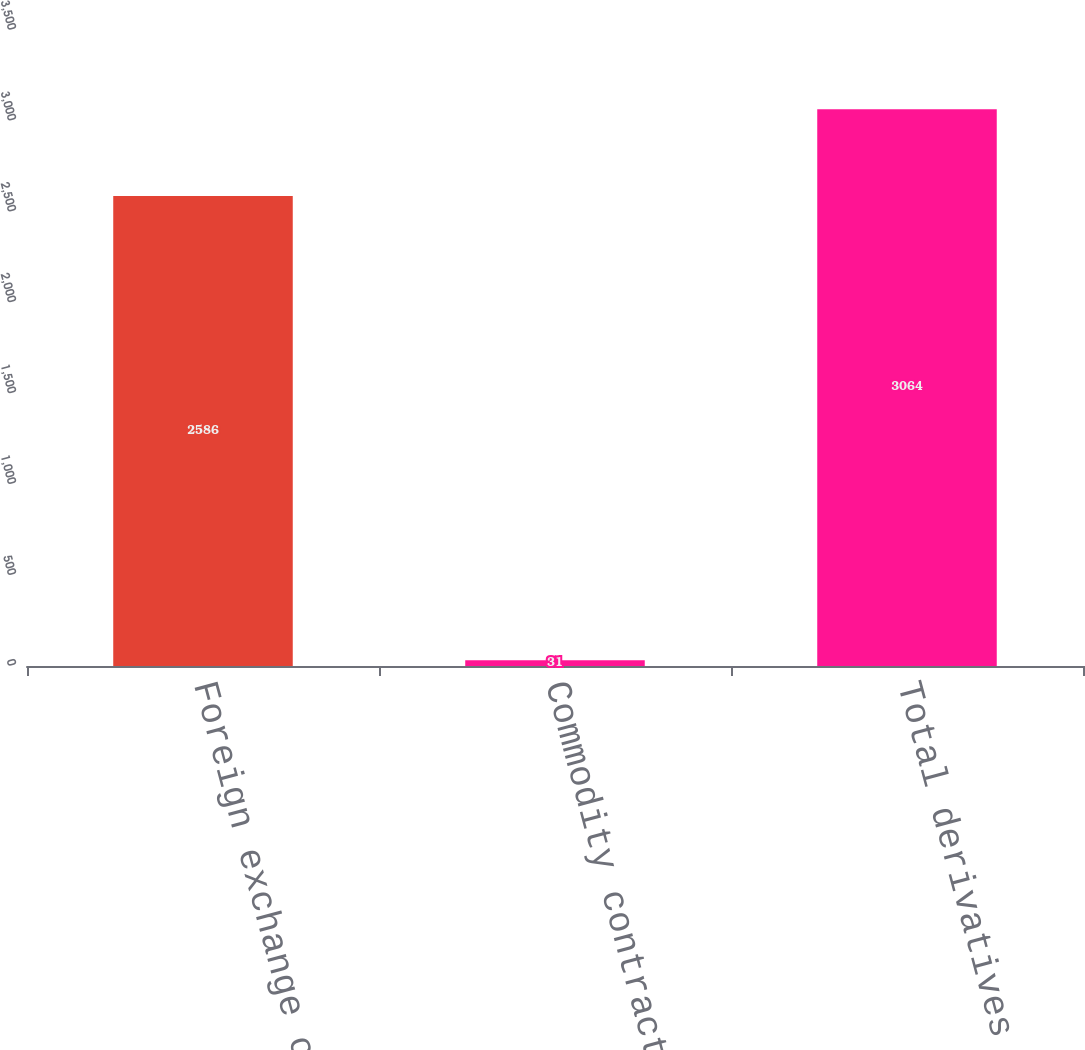Convert chart to OTSL. <chart><loc_0><loc_0><loc_500><loc_500><bar_chart><fcel>Foreign exchange contracts<fcel>Commodity contracts<fcel>Total derivatives<nl><fcel>2586<fcel>31<fcel>3064<nl></chart> 